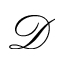<formula> <loc_0><loc_0><loc_500><loc_500>\mathcal { D }</formula> 